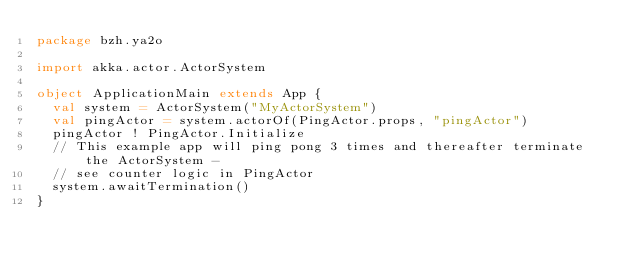Convert code to text. <code><loc_0><loc_0><loc_500><loc_500><_Scala_>package bzh.ya2o

import akka.actor.ActorSystem

object ApplicationMain extends App {
  val system = ActorSystem("MyActorSystem")
  val pingActor = system.actorOf(PingActor.props, "pingActor")
  pingActor ! PingActor.Initialize
  // This example app will ping pong 3 times and thereafter terminate the ActorSystem - 
  // see counter logic in PingActor
  system.awaitTermination()
}
</code> 